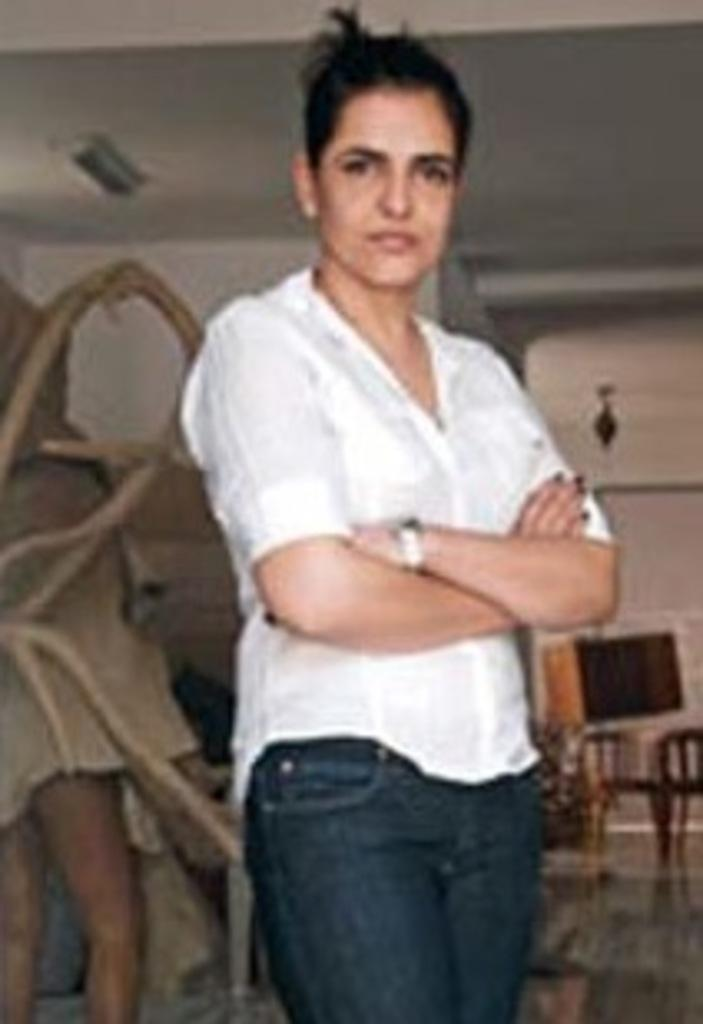What is the main subject of the image? There is a woman standing in the image. What can be seen in the background of the image? There are objects visible in the background of the image, including the ceiling and the wall. How many cherries are hanging from the string in the image? There is no string or cherries present in the image. What type of truck can be seen driving by in the image? There is no truck visible in the image. 